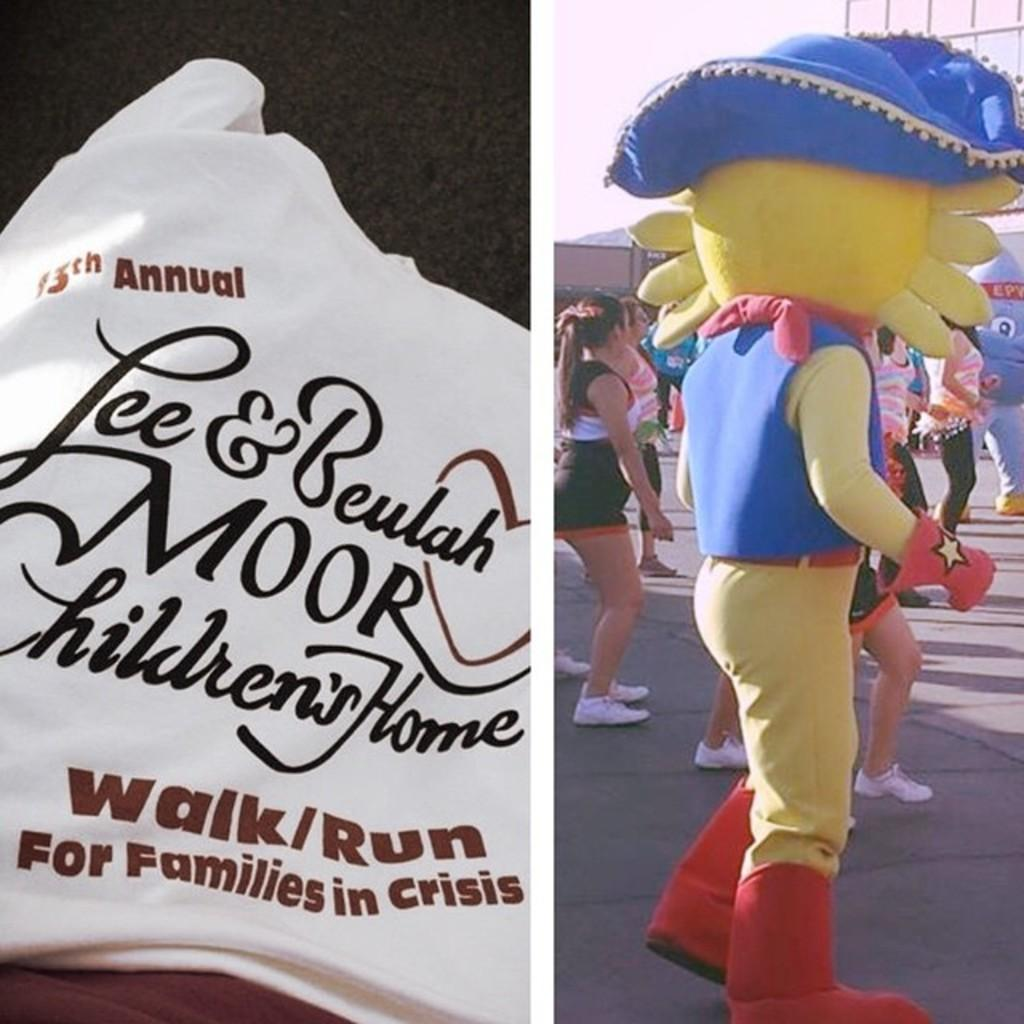What type of artwork is the image? The image is a collage. What can be seen on the left side of the collage? There is something written on a white cloth on the left side. What is present on the right side of the collage? There are people in the image on the right side, including a person in a costume. How many quince are present in the image? There are no quince visible in the image. Can you describe the duck in the image? There is no duck present in the image. 